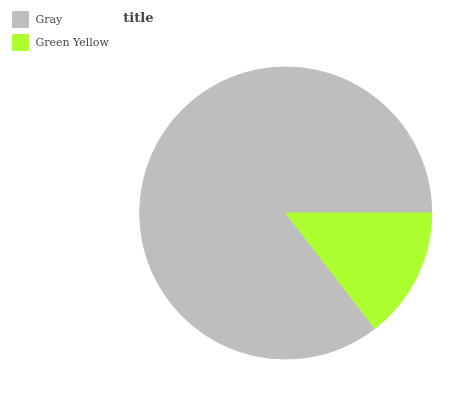Is Green Yellow the minimum?
Answer yes or no. Yes. Is Gray the maximum?
Answer yes or no. Yes. Is Green Yellow the maximum?
Answer yes or no. No. Is Gray greater than Green Yellow?
Answer yes or no. Yes. Is Green Yellow less than Gray?
Answer yes or no. Yes. Is Green Yellow greater than Gray?
Answer yes or no. No. Is Gray less than Green Yellow?
Answer yes or no. No. Is Gray the high median?
Answer yes or no. Yes. Is Green Yellow the low median?
Answer yes or no. Yes. Is Green Yellow the high median?
Answer yes or no. No. Is Gray the low median?
Answer yes or no. No. 